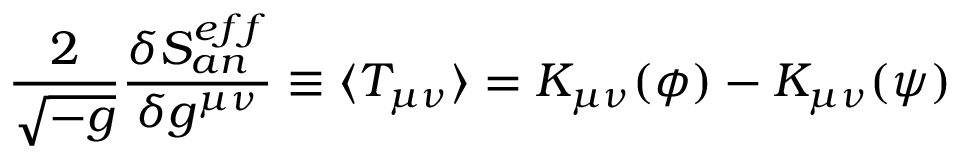Convert formula to latex. <formula><loc_0><loc_0><loc_500><loc_500>\frac { 2 } { \sqrt { - g } } \frac { \delta S _ { a n } ^ { e f f } } { \delta g ^ { \mu \nu } } \equiv \langle T _ { \mu \nu } \rangle = K _ { \mu \nu } ( \phi ) - K _ { \mu \nu } ( \psi )</formula> 